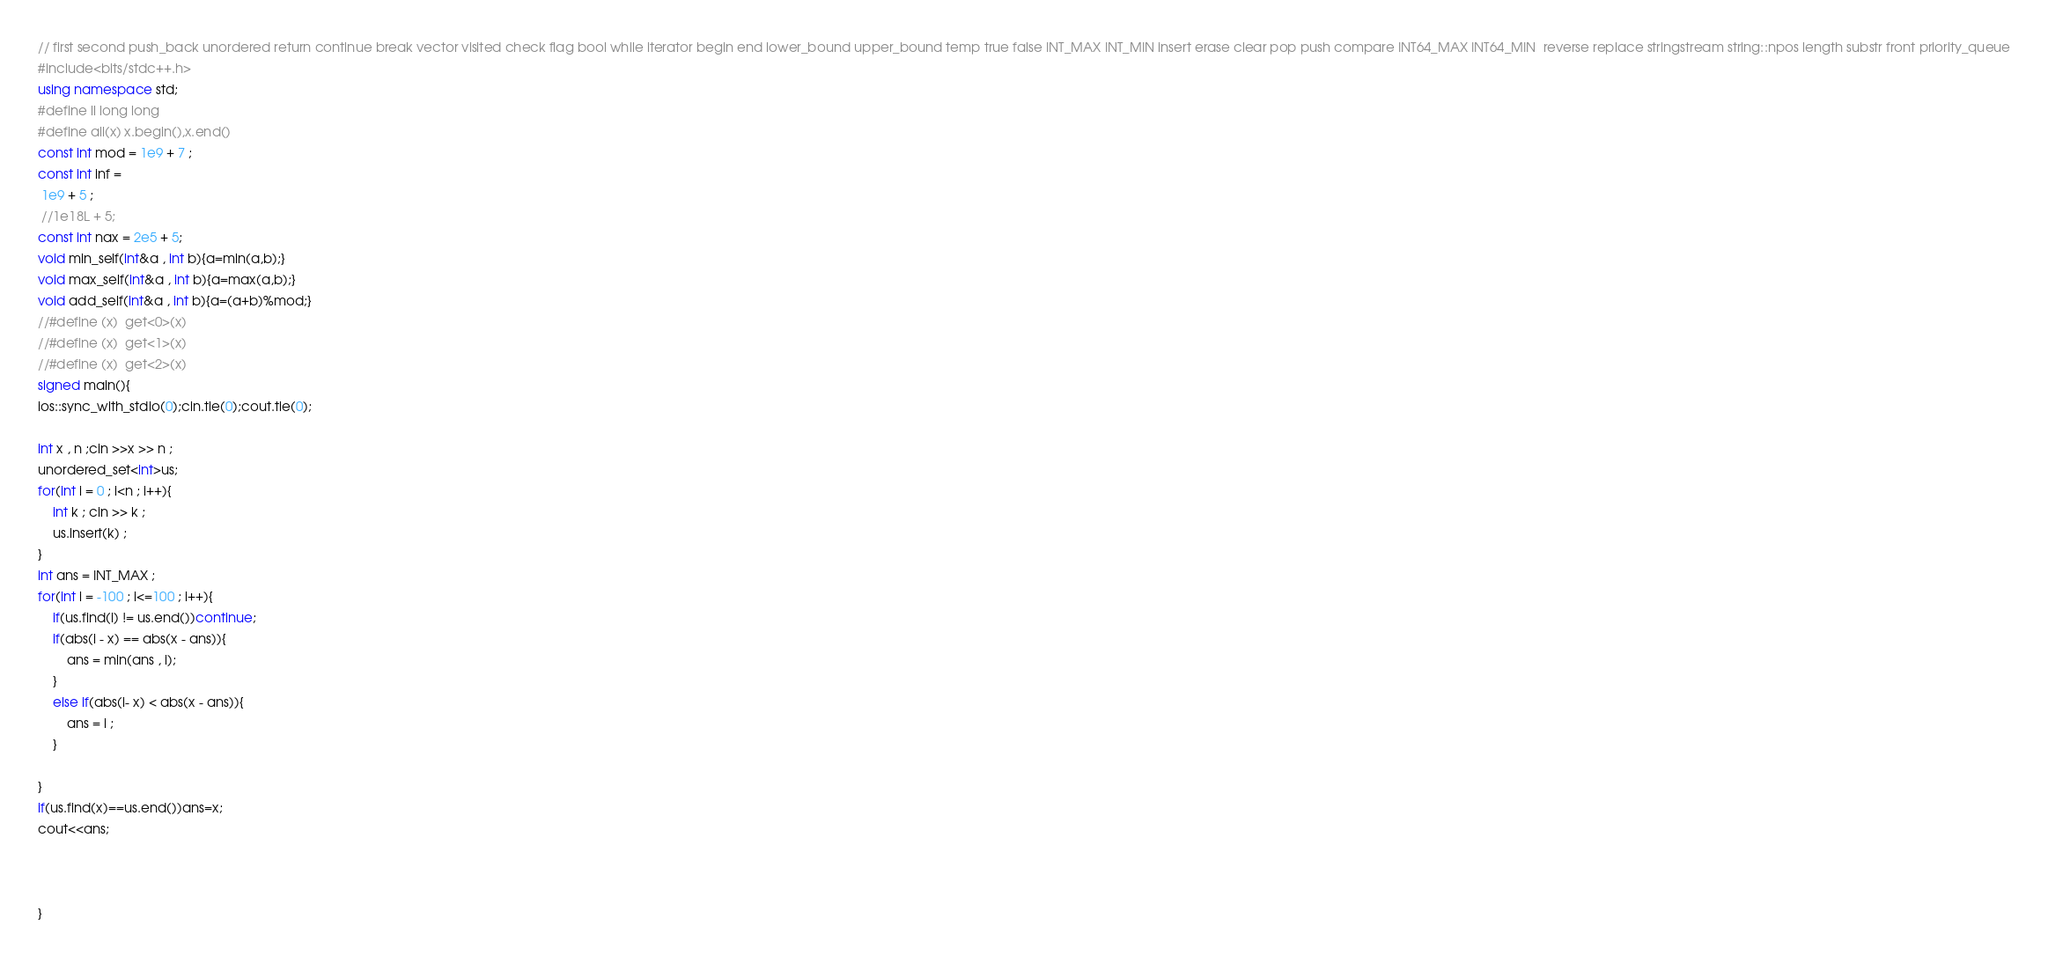<code> <loc_0><loc_0><loc_500><loc_500><_C++_>// first second push_back unordered return continue break vector visited check flag bool while iterator begin end lower_bound upper_bound temp true false INT_MAX INT_MIN insert erase clear pop push compare INT64_MAX INT64_MIN  reverse replace stringstream string::npos length substr front priority_queue
#include<bits/stdc++.h>
using namespace std;
#define ll long long
#define all(x) x.begin(),x.end()
const int mod = 1e9 + 7 ;
const int inf =
 1e9 + 5 ;
 //1e18L + 5;
const int nax = 2e5 + 5;
void min_self(int&a , int b){a=min(a,b);}
void max_self(int&a , int b){a=max(a,b);}
void add_self(int&a , int b){a=(a+b)%mod;}
//#define (x)  get<0>(x) 
//#define (x)  get<1>(x)
//#define (x)  get<2>(x)
signed main(){
ios::sync_with_stdio(0);cin.tie(0);cout.tie(0);

int x , n ;cin >>x >> n ; 
unordered_set<int>us;
for(int i = 0 ; i<n ; i++){
	int k ; cin >> k ; 
	us.insert(k) ; 
} 
int ans = INT_MAX ; 
for(int i = -100 ; i<=100 ; i++){
	if(us.find(i) != us.end())continue;
	if(abs(i - x) == abs(x - ans)){
		ans = min(ans , i);
	}
	else if(abs(i- x) < abs(x - ans)){
		ans = i ;
	}
	
}
if(us.find(x)==us.end())ans=x;
cout<<ans;
	

	
}</code> 